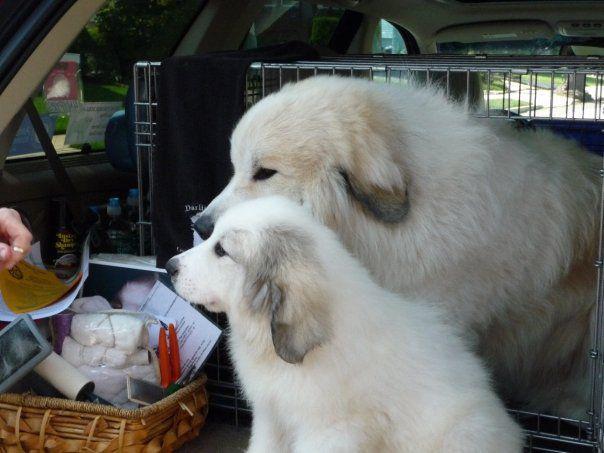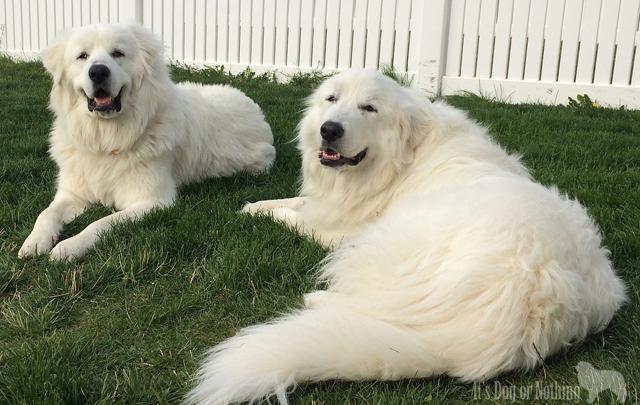The first image is the image on the left, the second image is the image on the right. Given the left and right images, does the statement "In one image, a large white dog is lounging on a sofa, with its tail hanging over the front." hold true? Answer yes or no. No. The first image is the image on the left, the second image is the image on the right. For the images displayed, is the sentence "An image shows a white dog draped across seating furniture." factually correct? Answer yes or no. No. 